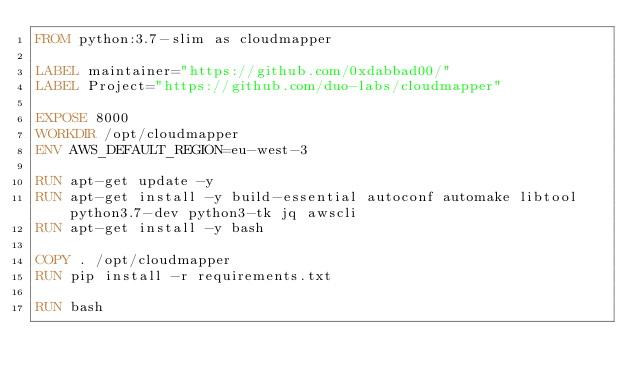Convert code to text. <code><loc_0><loc_0><loc_500><loc_500><_Dockerfile_>FROM python:3.7-slim as cloudmapper

LABEL maintainer="https://github.com/0xdabbad00/"
LABEL Project="https://github.com/duo-labs/cloudmapper"

EXPOSE 8000
WORKDIR /opt/cloudmapper
ENV AWS_DEFAULT_REGION=eu-west-3

RUN apt-get update -y
RUN apt-get install -y build-essential autoconf automake libtool python3.7-dev python3-tk jq awscli
RUN apt-get install -y bash

COPY . /opt/cloudmapper
RUN pip install -r requirements.txt

RUN bash
</code> 